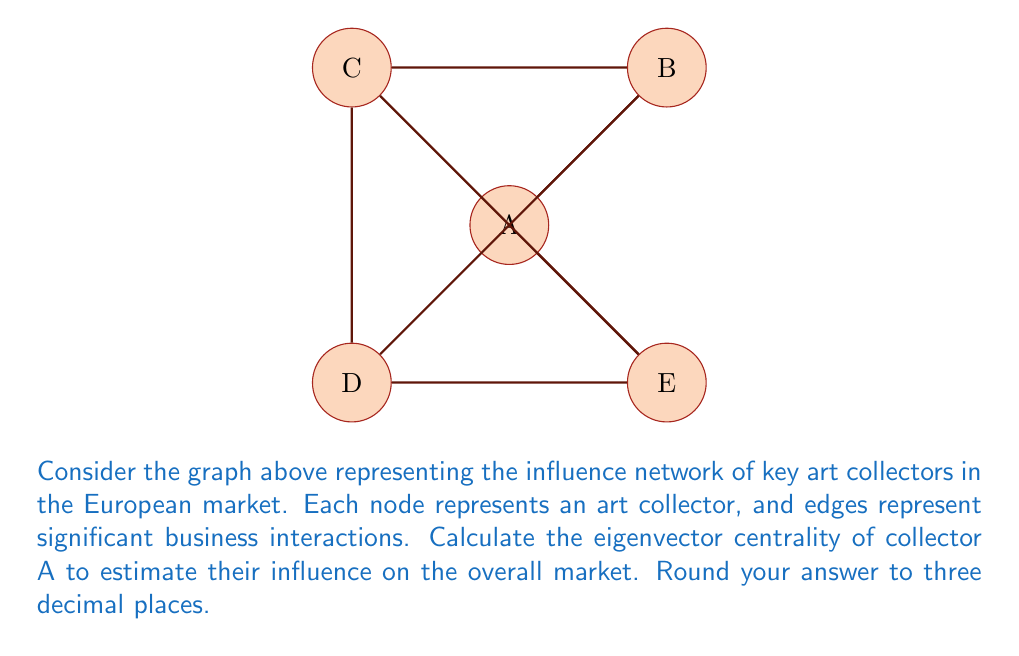Give your solution to this math problem. To calculate the eigenvector centrality, we follow these steps:

1) First, we create the adjacency matrix for the graph:

   $$
   M = \begin{bmatrix}
   0 & 1 & 1 & 1 & 1 \\
   1 & 0 & 1 & 1 & 0 \\
   1 & 1 & 0 & 0 & 1 \\
   1 & 1 & 0 & 0 & 1 \\
   1 & 0 & 1 & 1 & 0
   \end{bmatrix}
   $$

2) The eigenvector centrality is given by the principal eigenvector of this matrix. We need to solve:

   $$M\vec{v} = \lambda\vec{v}$$

   where $\lambda$ is the largest eigenvalue and $\vec{v}$ is the corresponding eigenvector.

3) Using a numerical method (like the power iteration method), we can find that the largest eigenvalue is approximately 3.236, and the corresponding eigenvector is:

   $$\vec{v} \approx [0.5257, 0.4323, 0.4323, 0.4323, 0.4323]^T$$

4) We normalize this vector so that the sum of its components is 1:

   $$\vec{v}_{\text{normalized}} \approx [0.2361, 0.1941, 0.1941, 0.1941, 0.1941]^T$$

5) The eigenvector centrality of collector A is the first component of this normalized vector: 0.2361.

6) Rounding to three decimal places, we get 0.236.
Answer: 0.236 